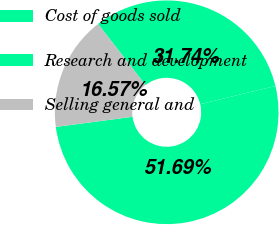<chart> <loc_0><loc_0><loc_500><loc_500><pie_chart><fcel>Cost of goods sold<fcel>Research and development<fcel>Selling general and<nl><fcel>31.74%<fcel>51.7%<fcel>16.57%<nl></chart> 